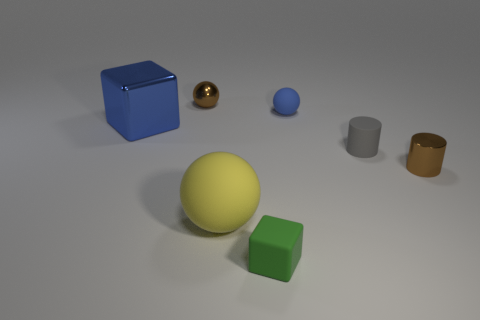Subtract all rubber balls. How many balls are left? 1 Subtract all blue blocks. How many blocks are left? 1 Subtract all balls. How many objects are left? 4 Add 1 small purple metallic blocks. How many objects exist? 8 Subtract 1 blocks. How many blocks are left? 1 Subtract all blue cubes. How many yellow balls are left? 1 Add 2 blue blocks. How many blue blocks are left? 3 Add 1 green metal things. How many green metal things exist? 1 Subtract 0 yellow blocks. How many objects are left? 7 Subtract all gray cylinders. Subtract all blue spheres. How many cylinders are left? 1 